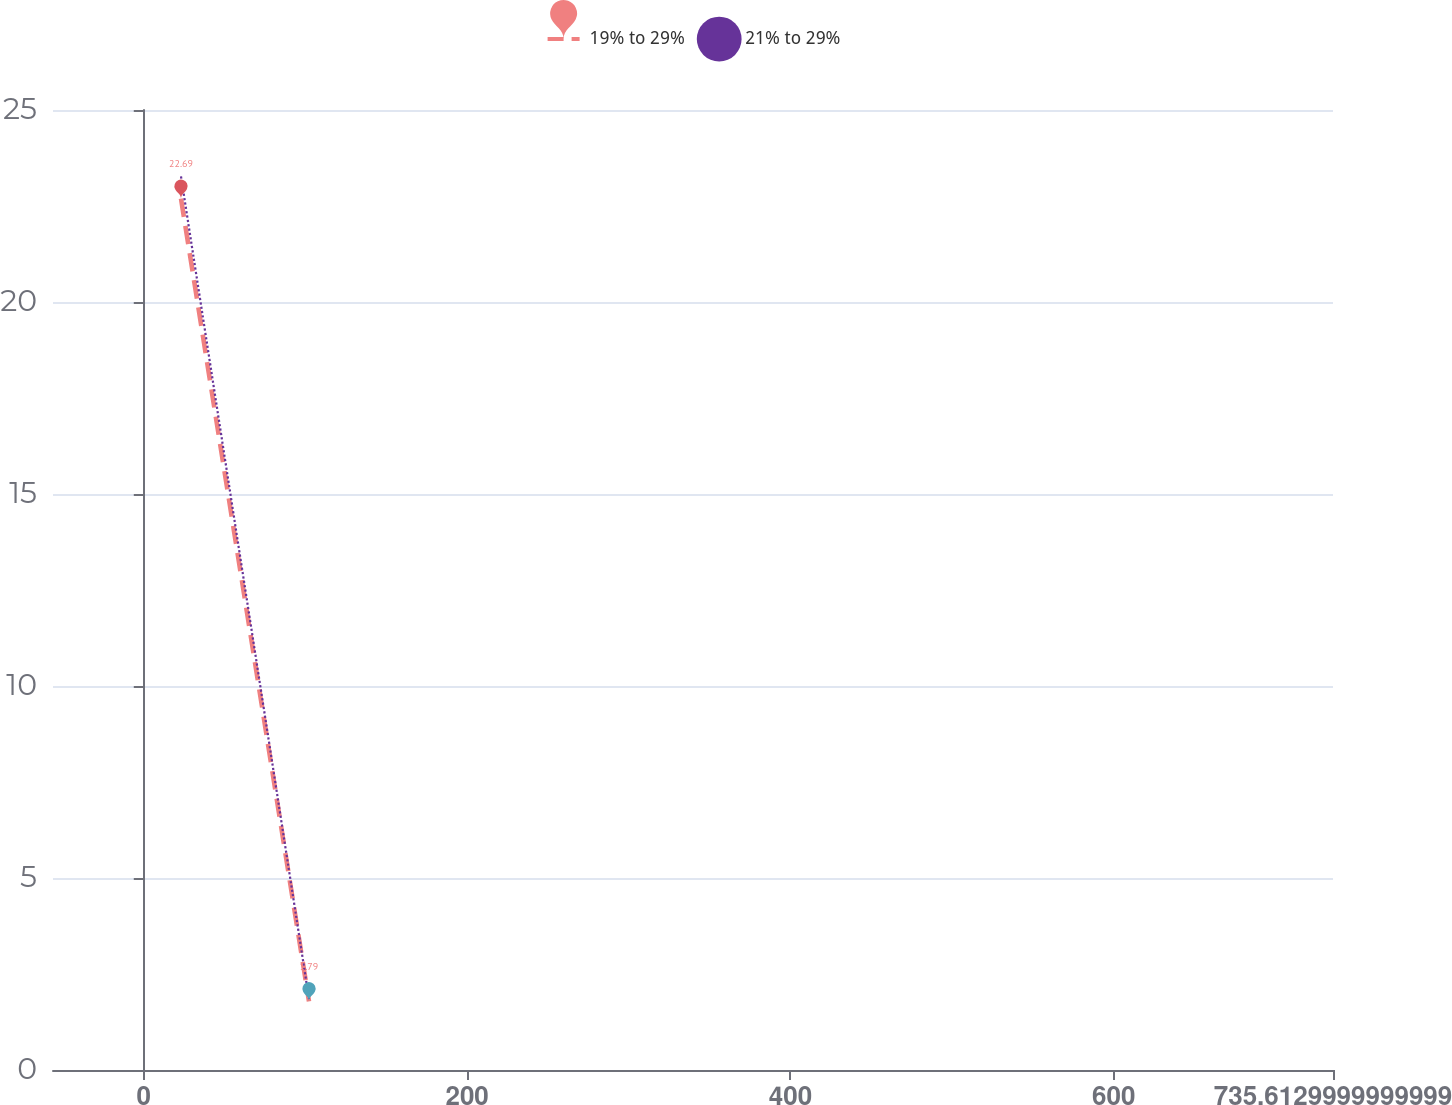Convert chart. <chart><loc_0><loc_0><loc_500><loc_500><line_chart><ecel><fcel>19% to 29%<fcel>21% to 29%<nl><fcel>23.02<fcel>22.69<fcel>23.27<nl><fcel>102.2<fcel>1.79<fcel>1.85<nl><fcel>814.79<fcel>12.05<fcel>16.05<nl></chart> 